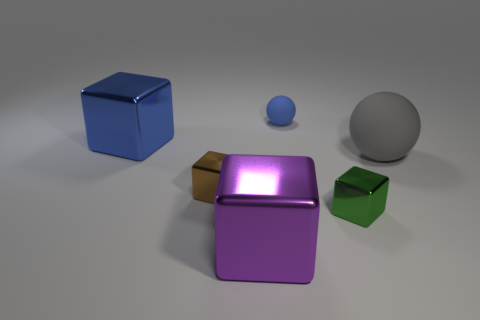Subtract all small green metallic blocks. How many blocks are left? 3 Add 4 rubber spheres. How many objects exist? 10 Subtract 2 balls. How many balls are left? 0 Subtract all gray balls. How many balls are left? 1 Subtract all balls. How many objects are left? 4 Add 5 gray objects. How many gray objects are left? 6 Add 4 big matte cubes. How many big matte cubes exist? 4 Subtract 1 blue spheres. How many objects are left? 5 Subtract all brown cubes. Subtract all cyan balls. How many cubes are left? 3 Subtract all big blue objects. Subtract all purple things. How many objects are left? 4 